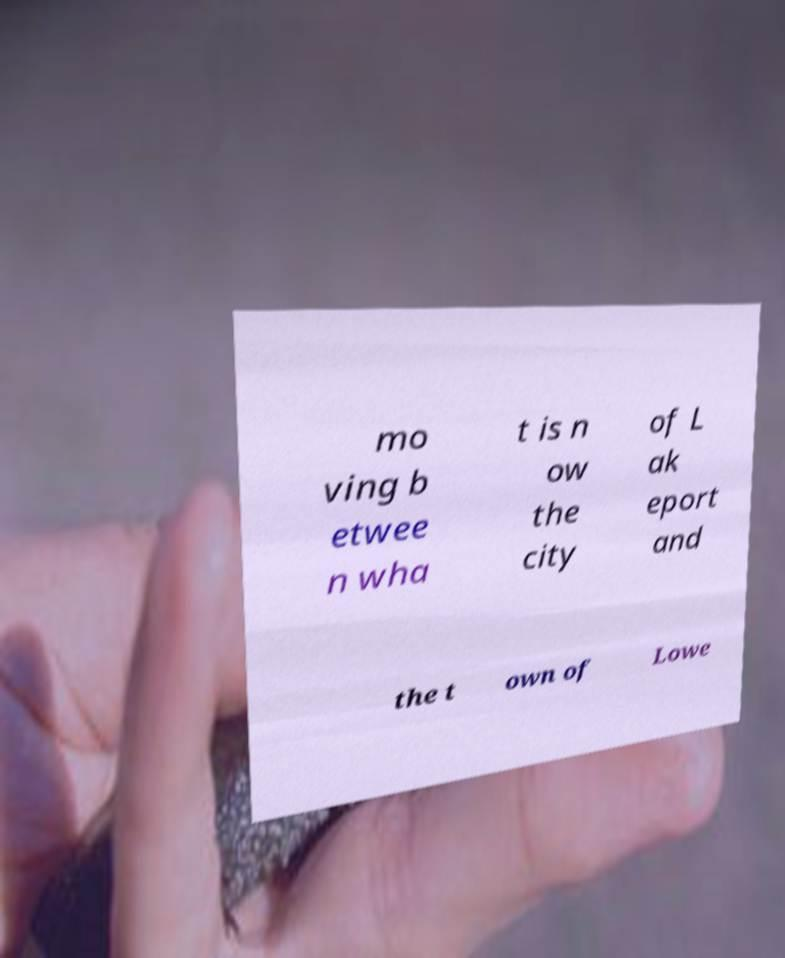I need the written content from this picture converted into text. Can you do that? mo ving b etwee n wha t is n ow the city of L ak eport and the t own of Lowe 